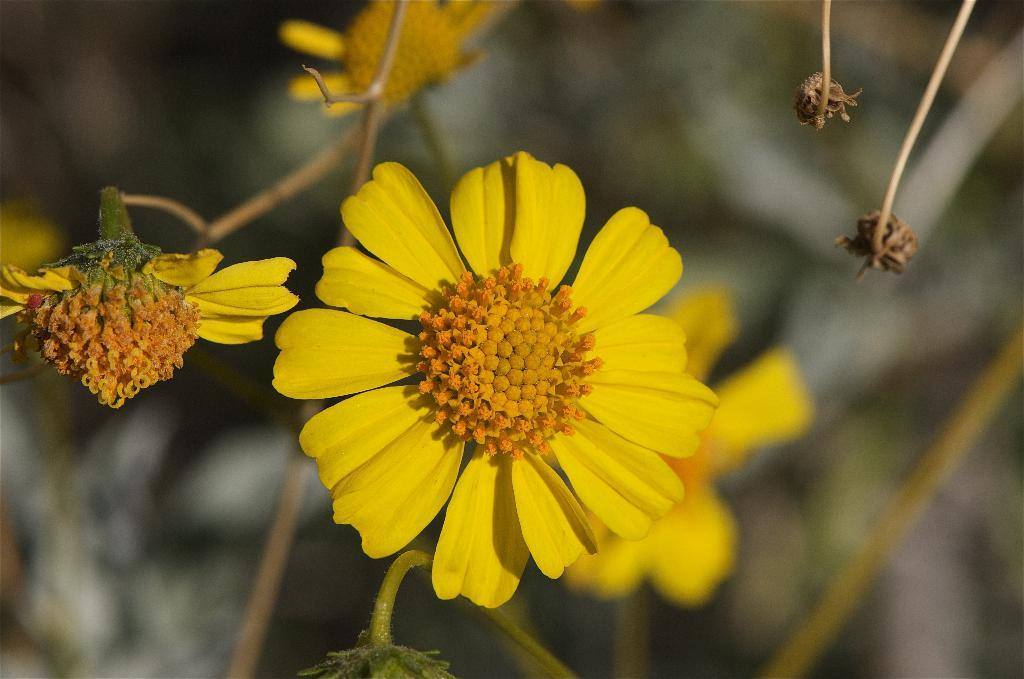What type of plant can be seen in the image? There is a plant in the image. What is the most prominent feature of the plant? The plant has a flower. What color is the flower? The flower is yellow in color. How many petals does the flower have? The flower has petals. What else can be seen on the plant in the image? There are dried buds of the plant visible in the image. What type of mint is being used in the protest shown in the image? There is no protest or mint present in the image; it features a plant with a yellow flower and dried buds. What type of quince is being displayed on the plant in the image? There is no quince present in the image; it features a plant with a yellow flower and dried buds. 